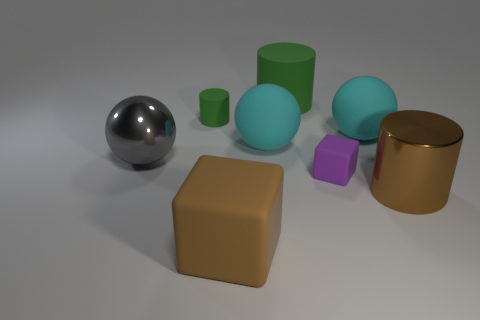Subtract all tiny matte cylinders. How many cylinders are left? 2 Subtract all yellow balls. How many green cylinders are left? 2 Add 1 metallic cylinders. How many objects exist? 9 Subtract all brown blocks. How many blocks are left? 1 Add 7 small cyan matte blocks. How many small cyan matte blocks exist? 7 Subtract 0 gray cylinders. How many objects are left? 8 Subtract all cylinders. How many objects are left? 5 Subtract all brown cubes. Subtract all cyan spheres. How many cubes are left? 1 Subtract all big blue blocks. Subtract all small green objects. How many objects are left? 7 Add 3 big cyan spheres. How many big cyan spheres are left? 5 